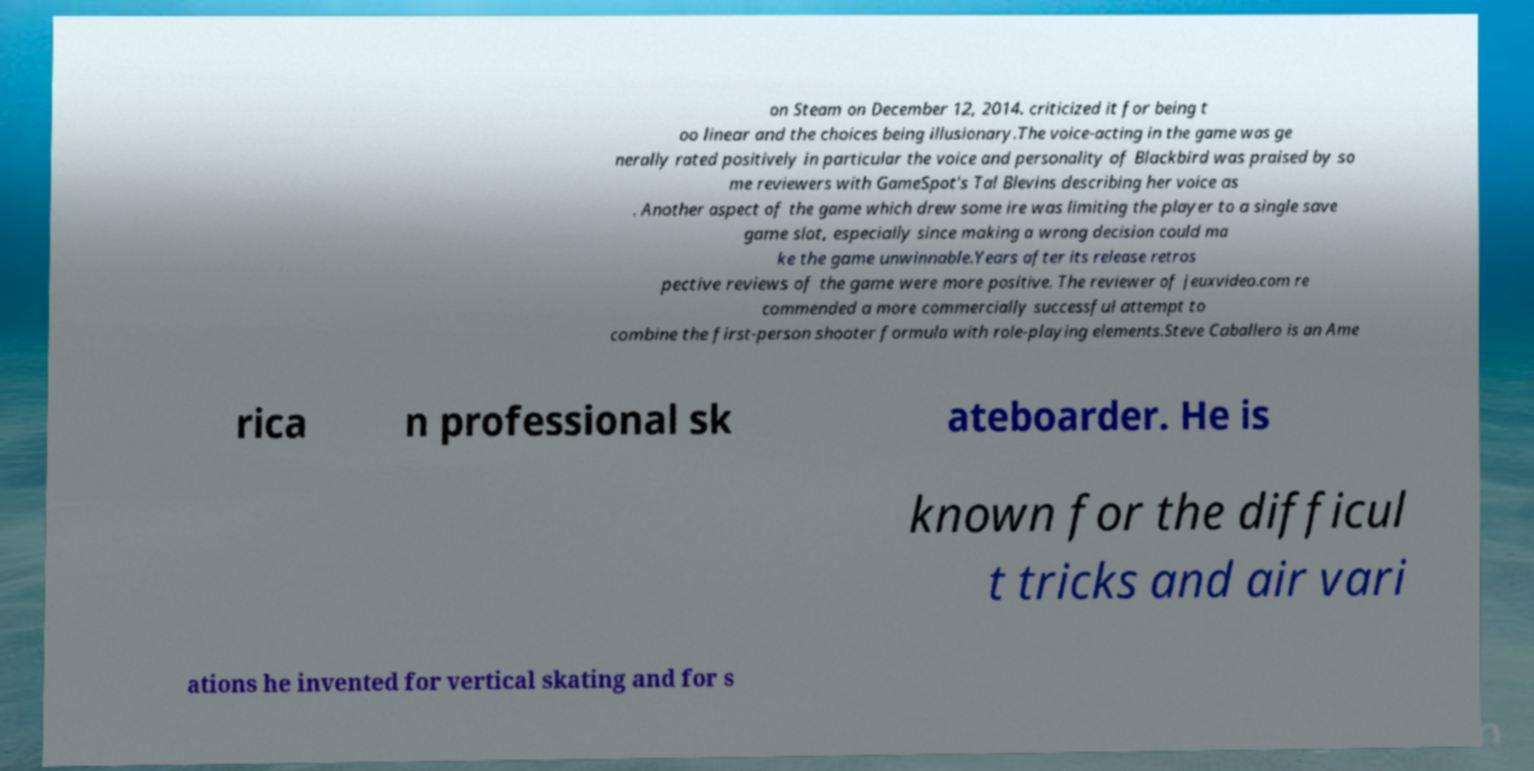Please identify and transcribe the text found in this image. on Steam on December 12, 2014. criticized it for being t oo linear and the choices being illusionary.The voice-acting in the game was ge nerally rated positively in particular the voice and personality of Blackbird was praised by so me reviewers with GameSpot's Tal Blevins describing her voice as . Another aspect of the game which drew some ire was limiting the player to a single save game slot, especially since making a wrong decision could ma ke the game unwinnable.Years after its release retros pective reviews of the game were more positive. The reviewer of jeuxvideo.com re commended a more commercially successful attempt to combine the first-person shooter formula with role-playing elements.Steve Caballero is an Ame rica n professional sk ateboarder. He is known for the difficul t tricks and air vari ations he invented for vertical skating and for s 